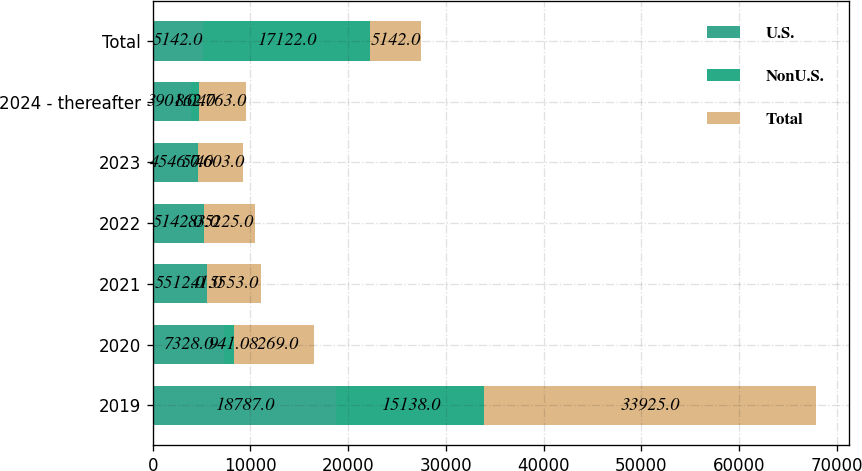Convert chart. <chart><loc_0><loc_0><loc_500><loc_500><stacked_bar_chart><ecel><fcel>2019<fcel>2020<fcel>2021<fcel>2022<fcel>2023<fcel>2024 - thereafter<fcel>Total<nl><fcel>U.S.<fcel>18787<fcel>7328<fcel>5512<fcel>5142<fcel>4546<fcel>3901<fcel>5142<nl><fcel>NonU.S.<fcel>15138<fcel>941<fcel>41<fcel>83<fcel>57<fcel>862<fcel>17122<nl><fcel>Total<fcel>33925<fcel>8269<fcel>5553<fcel>5225<fcel>4603<fcel>4763<fcel>5142<nl></chart> 